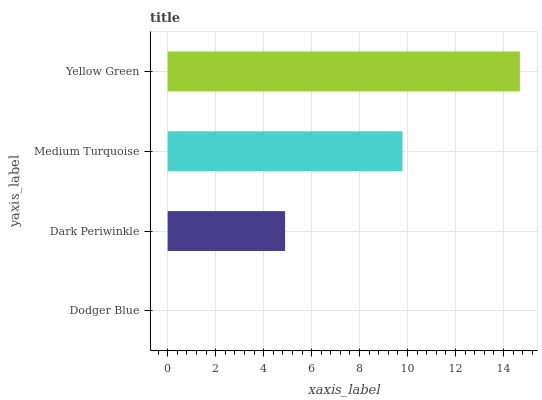Is Dodger Blue the minimum?
Answer yes or no. Yes. Is Yellow Green the maximum?
Answer yes or no. Yes. Is Dark Periwinkle the minimum?
Answer yes or no. No. Is Dark Periwinkle the maximum?
Answer yes or no. No. Is Dark Periwinkle greater than Dodger Blue?
Answer yes or no. Yes. Is Dodger Blue less than Dark Periwinkle?
Answer yes or no. Yes. Is Dodger Blue greater than Dark Periwinkle?
Answer yes or no. No. Is Dark Periwinkle less than Dodger Blue?
Answer yes or no. No. Is Medium Turquoise the high median?
Answer yes or no. Yes. Is Dark Periwinkle the low median?
Answer yes or no. Yes. Is Dodger Blue the high median?
Answer yes or no. No. Is Medium Turquoise the low median?
Answer yes or no. No. 